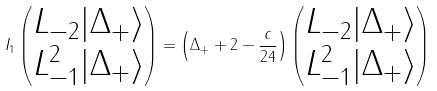<formula> <loc_0><loc_0><loc_500><loc_500>I _ { 1 } \begin{pmatrix} L _ { - 2 } | \Delta _ { + } \rangle \\ L _ { - 1 } ^ { 2 } | \Delta _ { + } \rangle \end{pmatrix} = \left ( \Delta _ { + } + 2 - \frac { c } { 2 4 } \right ) \begin{pmatrix} L _ { - 2 } | \Delta _ { + } \rangle \\ L _ { - 1 } ^ { 2 } | \Delta _ { + } \rangle \end{pmatrix}</formula> 